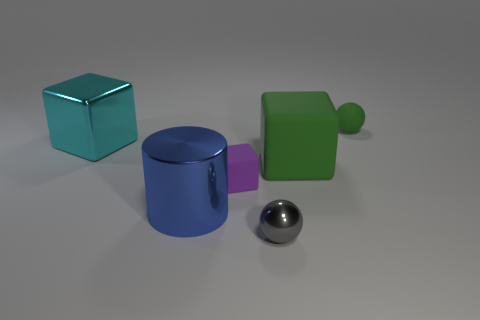The sphere that is the same color as the large rubber block is what size?
Offer a very short reply. Small. Do the small matte sphere and the small ball that is in front of the big blue thing have the same color?
Make the answer very short. No. What is the shape of the thing that is the same color as the large rubber block?
Keep it short and to the point. Sphere. What is the material of the tiny sphere right of the sphere on the left side of the green object to the left of the small green sphere?
Give a very brief answer. Rubber. Do the shiny object that is in front of the big cylinder and the large cyan metal object have the same shape?
Your answer should be very brief. No. What material is the object that is behind the cyan metallic block?
Provide a short and direct response. Rubber. What number of shiny things are red things or cubes?
Keep it short and to the point. 1. Is there a green metal block of the same size as the green rubber cube?
Give a very brief answer. No. Is the number of metal cylinders behind the small green rubber thing greater than the number of small things?
Provide a succinct answer. No. What number of big objects are gray spheres or rubber cubes?
Give a very brief answer. 1. 